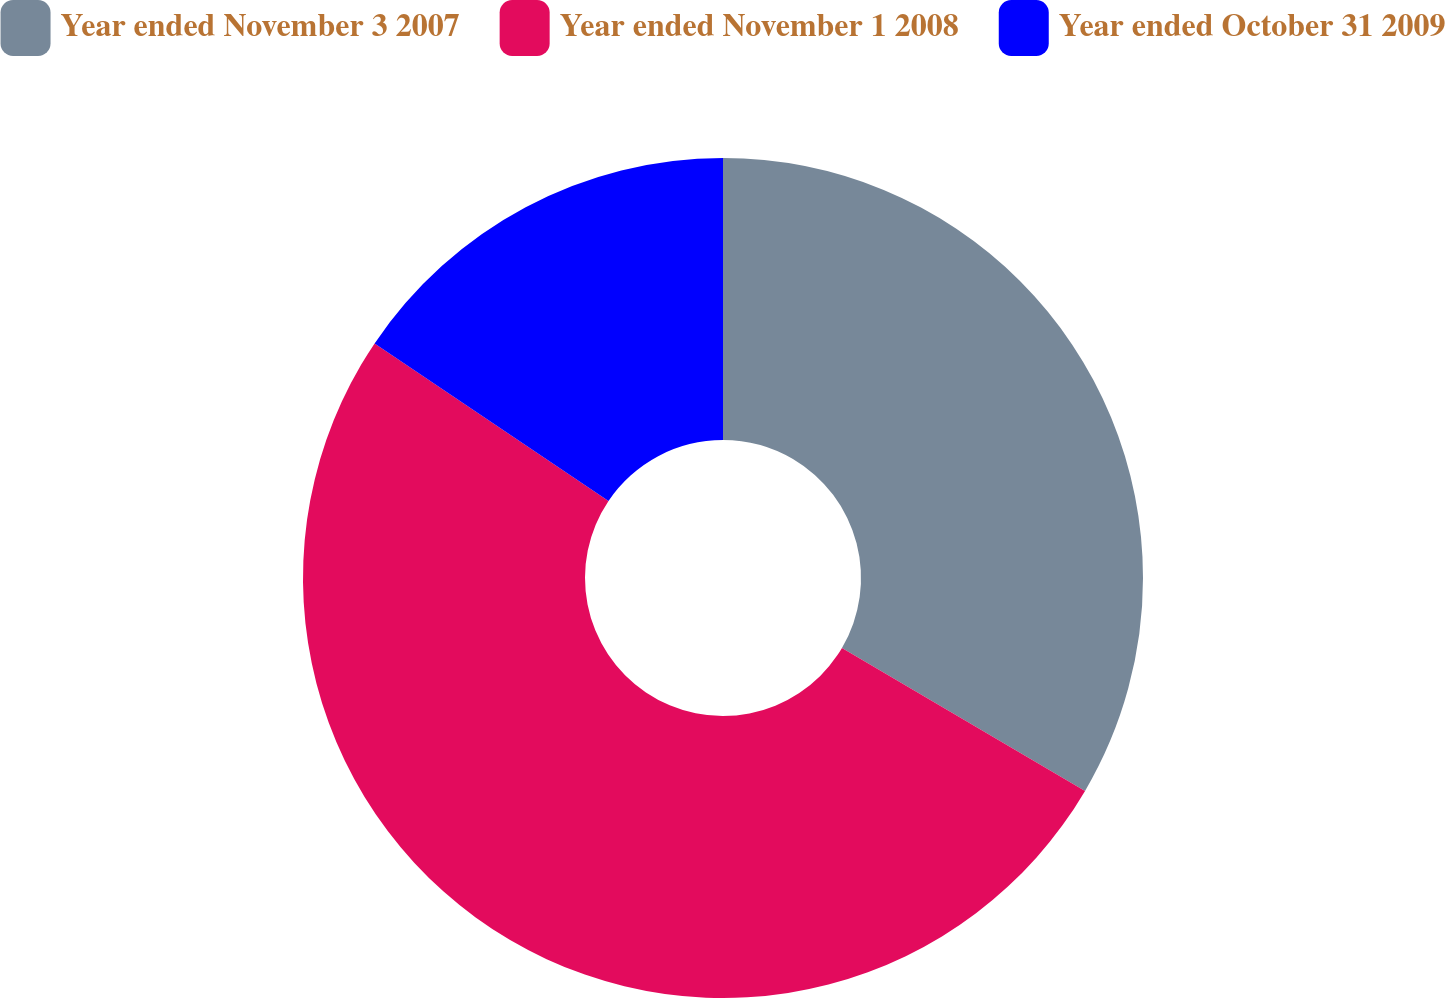Convert chart. <chart><loc_0><loc_0><loc_500><loc_500><pie_chart><fcel>Year ended November 3 2007<fcel>Year ended November 1 2008<fcel>Year ended October 31 2009<nl><fcel>33.46%<fcel>50.97%<fcel>15.57%<nl></chart> 